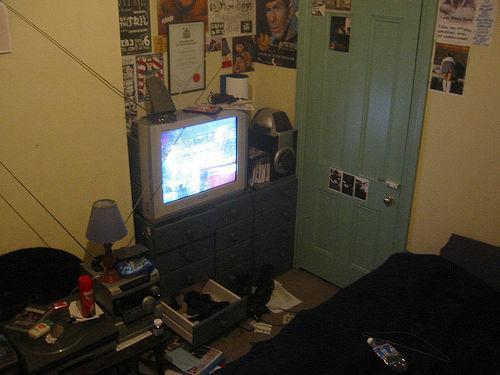How many drawers are open?
Give a very brief answer. 1. 